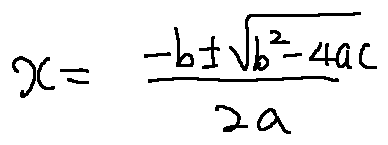<formula> <loc_0><loc_0><loc_500><loc_500>x = \frac { - b \pm \sqrt { b ^ { 2 } - 4 a c } } { 2 a }</formula> 